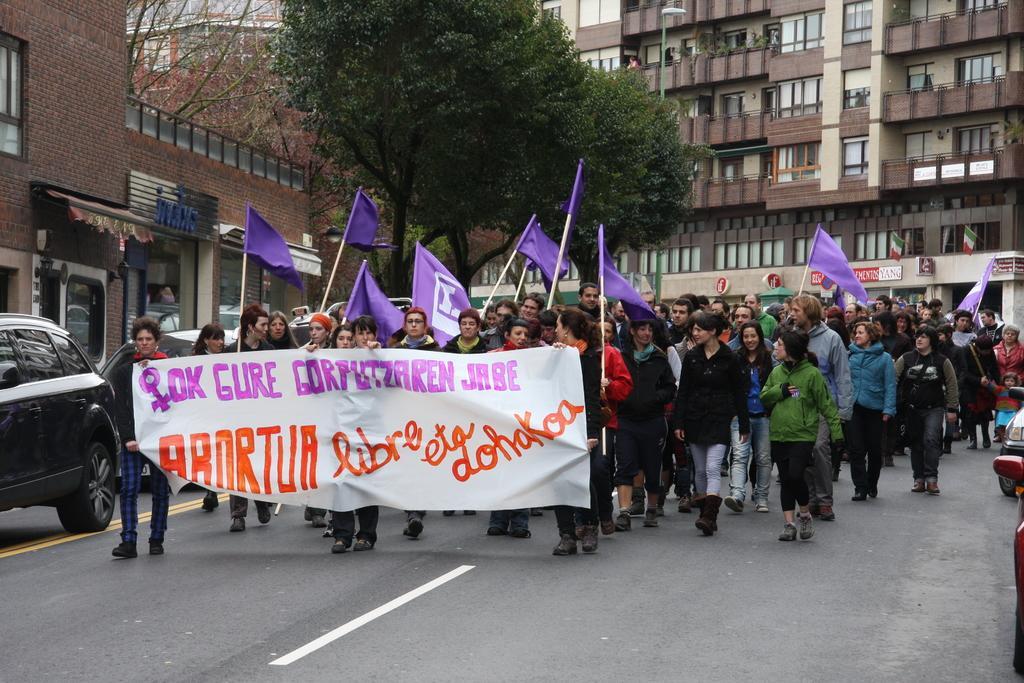In one or two sentences, can you explain what this image depicts? In this image people are holding flags and banner protesting on a road and there are cars, in the background there are buildings and trees. 